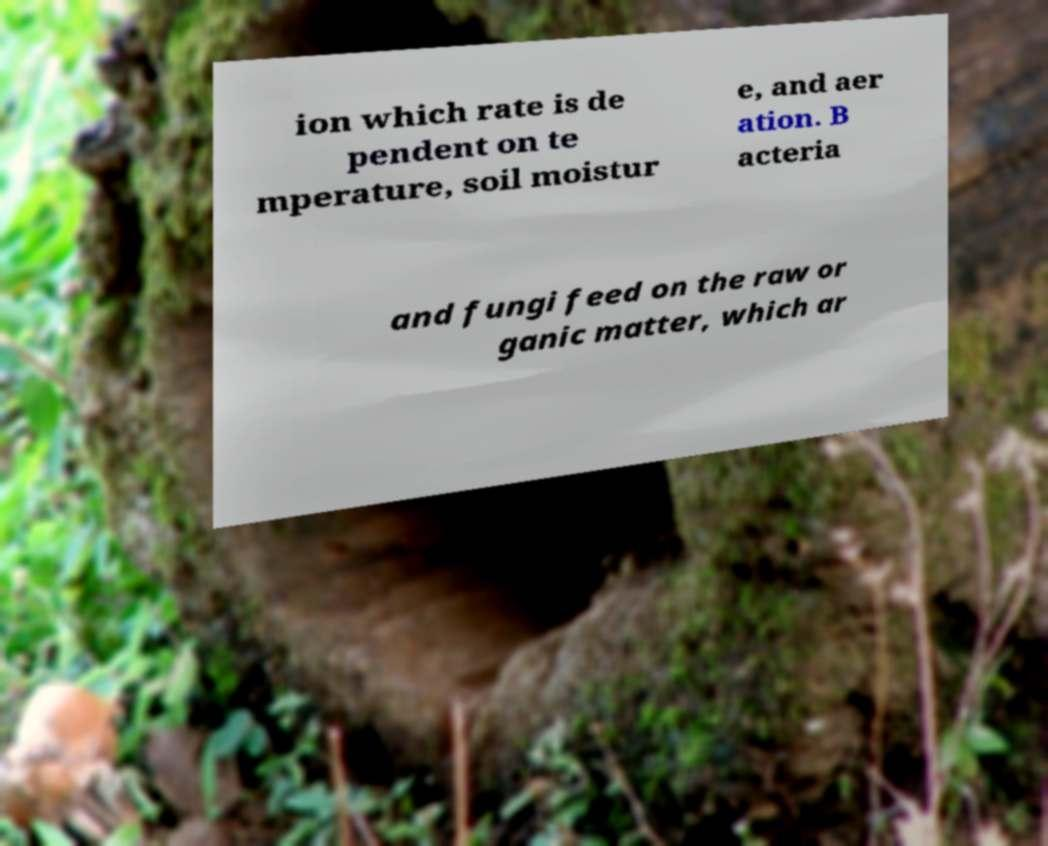What messages or text are displayed in this image? I need them in a readable, typed format. ion which rate is de pendent on te mperature, soil moistur e, and aer ation. B acteria and fungi feed on the raw or ganic matter, which ar 